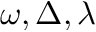Convert formula to latex. <formula><loc_0><loc_0><loc_500><loc_500>\omega , \Delta , \lambda</formula> 